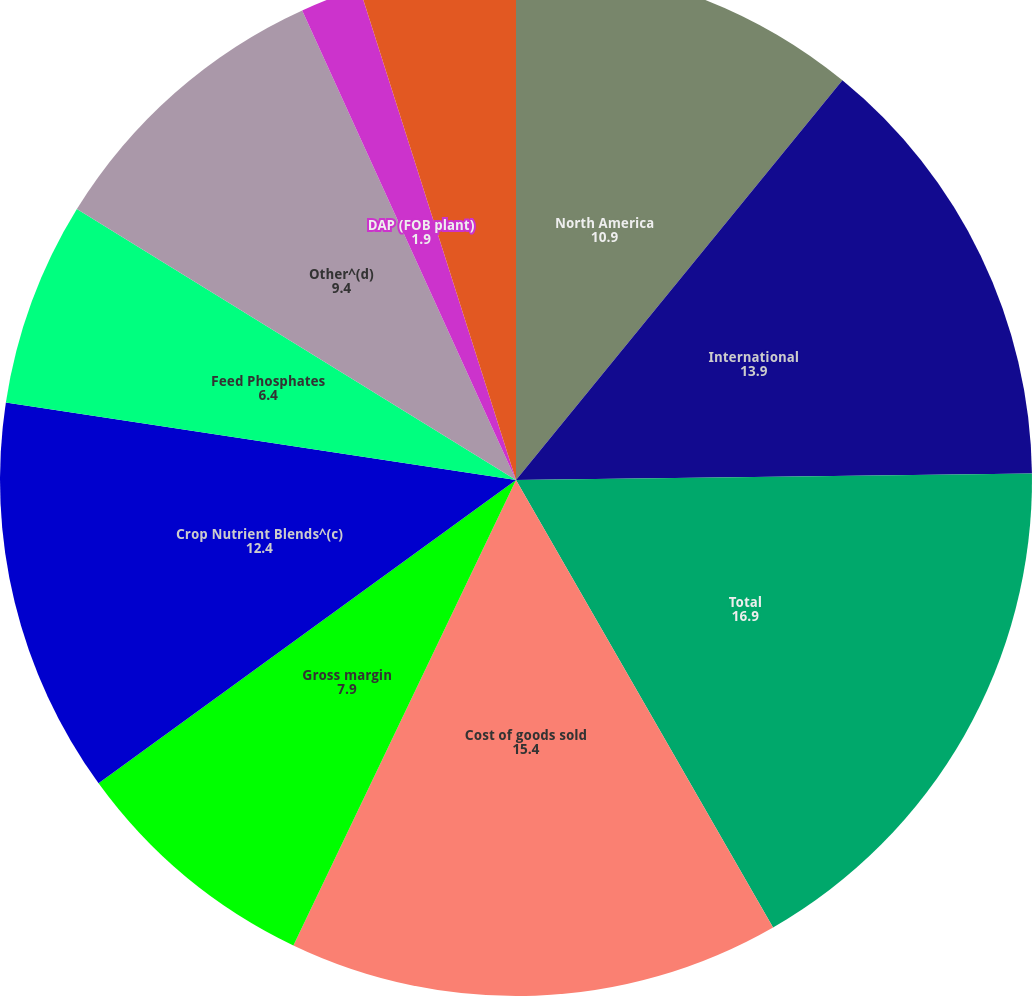Convert chart. <chart><loc_0><loc_0><loc_500><loc_500><pie_chart><fcel>North America<fcel>International<fcel>Total<fcel>Cost of goods sold<fcel>Gross margin<fcel>Crop Nutrient Blends^(c)<fcel>Feed Phosphates<fcel>Other^(d)<fcel>DAP (FOB plant)<fcel>Crop Nutrient Blends (FOB<nl><fcel>10.9%<fcel>13.9%<fcel>16.9%<fcel>15.4%<fcel>7.9%<fcel>12.4%<fcel>6.4%<fcel>9.4%<fcel>1.9%<fcel>4.9%<nl></chart> 